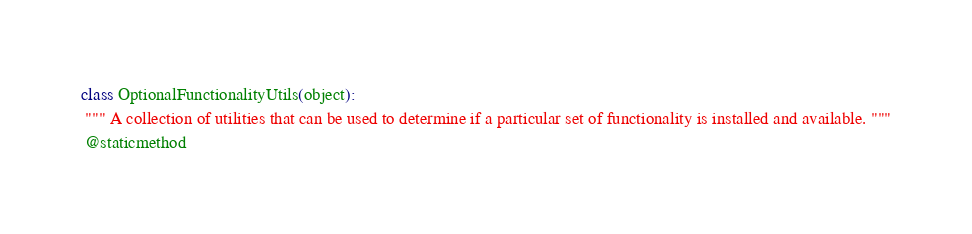Convert code to text. <code><loc_0><loc_0><loc_500><loc_500><_Python_>class OptionalFunctionalityUtils(object):
 """ A collection of utilities that can be used to determine if a particular set of functionality is installed and available. """
 @staticmethod</code> 